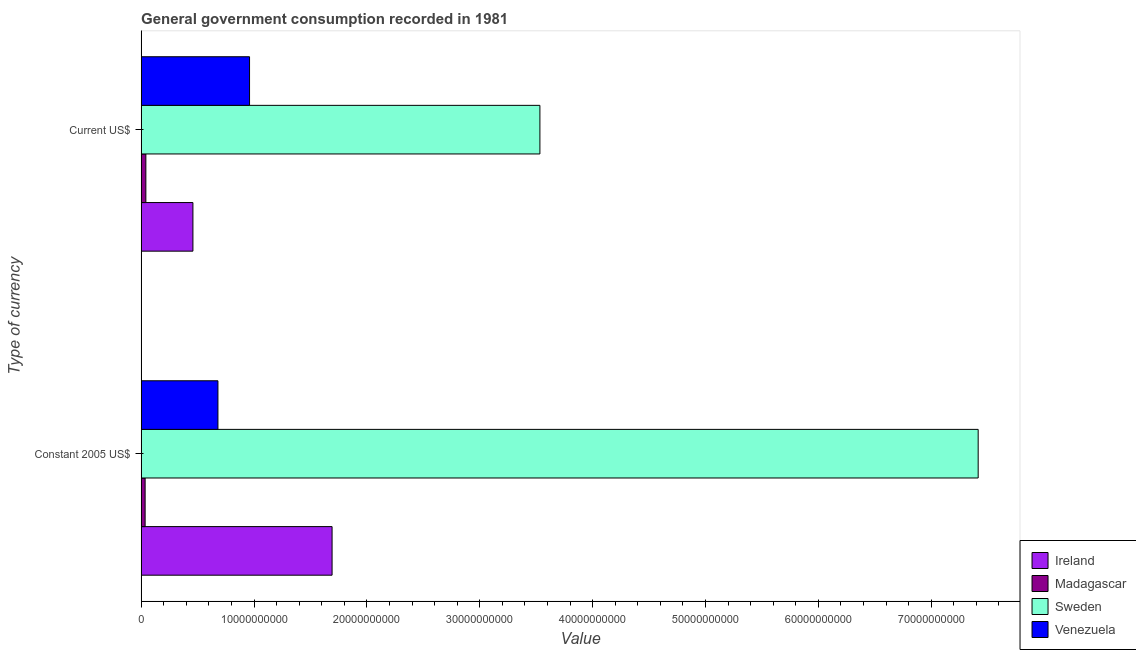How many groups of bars are there?
Make the answer very short. 2. Are the number of bars per tick equal to the number of legend labels?
Offer a very short reply. Yes. Are the number of bars on each tick of the Y-axis equal?
Ensure brevity in your answer.  Yes. How many bars are there on the 1st tick from the bottom?
Make the answer very short. 4. What is the label of the 2nd group of bars from the top?
Offer a very short reply. Constant 2005 US$. What is the value consumed in current us$ in Sweden?
Your answer should be compact. 3.53e+1. Across all countries, what is the maximum value consumed in current us$?
Offer a very short reply. 3.53e+1. Across all countries, what is the minimum value consumed in constant 2005 us$?
Your answer should be very brief. 3.52e+08. In which country was the value consumed in current us$ maximum?
Give a very brief answer. Sweden. In which country was the value consumed in constant 2005 us$ minimum?
Ensure brevity in your answer.  Madagascar. What is the total value consumed in current us$ in the graph?
Your answer should be very brief. 4.99e+1. What is the difference between the value consumed in constant 2005 us$ in Sweden and that in Venezuela?
Your response must be concise. 6.74e+1. What is the difference between the value consumed in constant 2005 us$ in Ireland and the value consumed in current us$ in Madagascar?
Your answer should be very brief. 1.65e+1. What is the average value consumed in constant 2005 us$ per country?
Your answer should be very brief. 2.46e+1. What is the difference between the value consumed in current us$ and value consumed in constant 2005 us$ in Sweden?
Ensure brevity in your answer.  -3.88e+1. In how many countries, is the value consumed in current us$ greater than 8000000000 ?
Offer a very short reply. 2. What is the ratio of the value consumed in constant 2005 us$ in Venezuela to that in Ireland?
Provide a short and direct response. 0.4. Is the value consumed in current us$ in Venezuela less than that in Ireland?
Your response must be concise. No. In how many countries, is the value consumed in current us$ greater than the average value consumed in current us$ taken over all countries?
Provide a succinct answer. 1. What does the 4th bar from the top in Current US$ represents?
Your response must be concise. Ireland. What does the 4th bar from the bottom in Current US$ represents?
Offer a very short reply. Venezuela. How many countries are there in the graph?
Your answer should be compact. 4. Does the graph contain any zero values?
Ensure brevity in your answer.  No. Where does the legend appear in the graph?
Your response must be concise. Bottom right. How many legend labels are there?
Provide a short and direct response. 4. What is the title of the graph?
Your answer should be very brief. General government consumption recorded in 1981. What is the label or title of the X-axis?
Keep it short and to the point. Value. What is the label or title of the Y-axis?
Your answer should be compact. Type of currency. What is the Value in Ireland in Constant 2005 US$?
Your answer should be very brief. 1.69e+1. What is the Value of Madagascar in Constant 2005 US$?
Your answer should be compact. 3.52e+08. What is the Value of Sweden in Constant 2005 US$?
Provide a succinct answer. 7.42e+1. What is the Value of Venezuela in Constant 2005 US$?
Provide a succinct answer. 6.80e+09. What is the Value in Ireland in Current US$?
Give a very brief answer. 4.59e+09. What is the Value of Madagascar in Current US$?
Keep it short and to the point. 4.17e+08. What is the Value in Sweden in Current US$?
Your response must be concise. 3.53e+1. What is the Value in Venezuela in Current US$?
Offer a very short reply. 9.60e+09. Across all Type of currency, what is the maximum Value in Ireland?
Provide a short and direct response. 1.69e+1. Across all Type of currency, what is the maximum Value in Madagascar?
Keep it short and to the point. 4.17e+08. Across all Type of currency, what is the maximum Value of Sweden?
Ensure brevity in your answer.  7.42e+1. Across all Type of currency, what is the maximum Value of Venezuela?
Give a very brief answer. 9.60e+09. Across all Type of currency, what is the minimum Value in Ireland?
Keep it short and to the point. 4.59e+09. Across all Type of currency, what is the minimum Value of Madagascar?
Offer a very short reply. 3.52e+08. Across all Type of currency, what is the minimum Value of Sweden?
Keep it short and to the point. 3.53e+1. Across all Type of currency, what is the minimum Value in Venezuela?
Keep it short and to the point. 6.80e+09. What is the total Value of Ireland in the graph?
Offer a terse response. 2.15e+1. What is the total Value of Madagascar in the graph?
Provide a succinct answer. 7.69e+08. What is the total Value in Sweden in the graph?
Your response must be concise. 1.09e+11. What is the total Value in Venezuela in the graph?
Your answer should be very brief. 1.64e+1. What is the difference between the Value of Ireland in Constant 2005 US$ and that in Current US$?
Your answer should be compact. 1.23e+1. What is the difference between the Value in Madagascar in Constant 2005 US$ and that in Current US$?
Your answer should be compact. -6.47e+07. What is the difference between the Value of Sweden in Constant 2005 US$ and that in Current US$?
Make the answer very short. 3.88e+1. What is the difference between the Value in Venezuela in Constant 2005 US$ and that in Current US$?
Provide a succinct answer. -2.80e+09. What is the difference between the Value in Ireland in Constant 2005 US$ and the Value in Madagascar in Current US$?
Offer a terse response. 1.65e+1. What is the difference between the Value in Ireland in Constant 2005 US$ and the Value in Sweden in Current US$?
Keep it short and to the point. -1.84e+1. What is the difference between the Value of Ireland in Constant 2005 US$ and the Value of Venezuela in Current US$?
Provide a succinct answer. 7.31e+09. What is the difference between the Value in Madagascar in Constant 2005 US$ and the Value in Sweden in Current US$?
Your answer should be compact. -3.50e+1. What is the difference between the Value of Madagascar in Constant 2005 US$ and the Value of Venezuela in Current US$?
Make the answer very short. -9.25e+09. What is the difference between the Value of Sweden in Constant 2005 US$ and the Value of Venezuela in Current US$?
Make the answer very short. 6.46e+1. What is the average Value in Ireland per Type of currency?
Your response must be concise. 1.08e+1. What is the average Value of Madagascar per Type of currency?
Ensure brevity in your answer.  3.85e+08. What is the average Value in Sweden per Type of currency?
Your answer should be compact. 5.47e+1. What is the average Value in Venezuela per Type of currency?
Your answer should be very brief. 8.20e+09. What is the difference between the Value in Ireland and Value in Madagascar in Constant 2005 US$?
Your answer should be compact. 1.66e+1. What is the difference between the Value in Ireland and Value in Sweden in Constant 2005 US$?
Offer a very short reply. -5.72e+1. What is the difference between the Value in Ireland and Value in Venezuela in Constant 2005 US$?
Ensure brevity in your answer.  1.01e+1. What is the difference between the Value in Madagascar and Value in Sweden in Constant 2005 US$?
Offer a very short reply. -7.38e+1. What is the difference between the Value of Madagascar and Value of Venezuela in Constant 2005 US$?
Give a very brief answer. -6.45e+09. What is the difference between the Value in Sweden and Value in Venezuela in Constant 2005 US$?
Your answer should be compact. 6.74e+1. What is the difference between the Value in Ireland and Value in Madagascar in Current US$?
Your answer should be very brief. 4.17e+09. What is the difference between the Value in Ireland and Value in Sweden in Current US$?
Provide a short and direct response. -3.07e+1. What is the difference between the Value in Ireland and Value in Venezuela in Current US$?
Offer a terse response. -5.02e+09. What is the difference between the Value in Madagascar and Value in Sweden in Current US$?
Your answer should be compact. -3.49e+1. What is the difference between the Value of Madagascar and Value of Venezuela in Current US$?
Your answer should be very brief. -9.19e+09. What is the difference between the Value in Sweden and Value in Venezuela in Current US$?
Give a very brief answer. 2.57e+1. What is the ratio of the Value of Ireland in Constant 2005 US$ to that in Current US$?
Provide a succinct answer. 3.69. What is the ratio of the Value in Madagascar in Constant 2005 US$ to that in Current US$?
Offer a very short reply. 0.84. What is the ratio of the Value of Sweden in Constant 2005 US$ to that in Current US$?
Your answer should be compact. 2.1. What is the ratio of the Value in Venezuela in Constant 2005 US$ to that in Current US$?
Offer a terse response. 0.71. What is the difference between the highest and the second highest Value of Ireland?
Offer a terse response. 1.23e+1. What is the difference between the highest and the second highest Value in Madagascar?
Your answer should be very brief. 6.47e+07. What is the difference between the highest and the second highest Value in Sweden?
Ensure brevity in your answer.  3.88e+1. What is the difference between the highest and the second highest Value of Venezuela?
Offer a very short reply. 2.80e+09. What is the difference between the highest and the lowest Value in Ireland?
Offer a terse response. 1.23e+1. What is the difference between the highest and the lowest Value in Madagascar?
Provide a succinct answer. 6.47e+07. What is the difference between the highest and the lowest Value of Sweden?
Provide a succinct answer. 3.88e+1. What is the difference between the highest and the lowest Value in Venezuela?
Make the answer very short. 2.80e+09. 